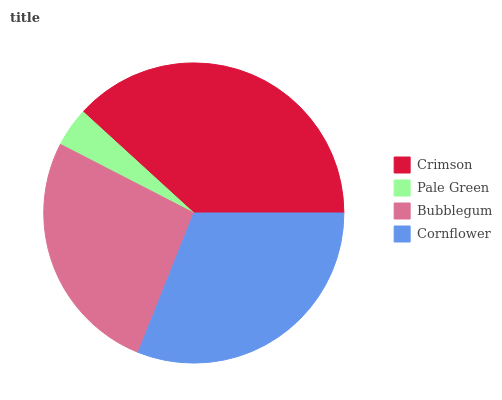Is Pale Green the minimum?
Answer yes or no. Yes. Is Crimson the maximum?
Answer yes or no. Yes. Is Bubblegum the minimum?
Answer yes or no. No. Is Bubblegum the maximum?
Answer yes or no. No. Is Bubblegum greater than Pale Green?
Answer yes or no. Yes. Is Pale Green less than Bubblegum?
Answer yes or no. Yes. Is Pale Green greater than Bubblegum?
Answer yes or no. No. Is Bubblegum less than Pale Green?
Answer yes or no. No. Is Cornflower the high median?
Answer yes or no. Yes. Is Bubblegum the low median?
Answer yes or no. Yes. Is Pale Green the high median?
Answer yes or no. No. Is Crimson the low median?
Answer yes or no. No. 